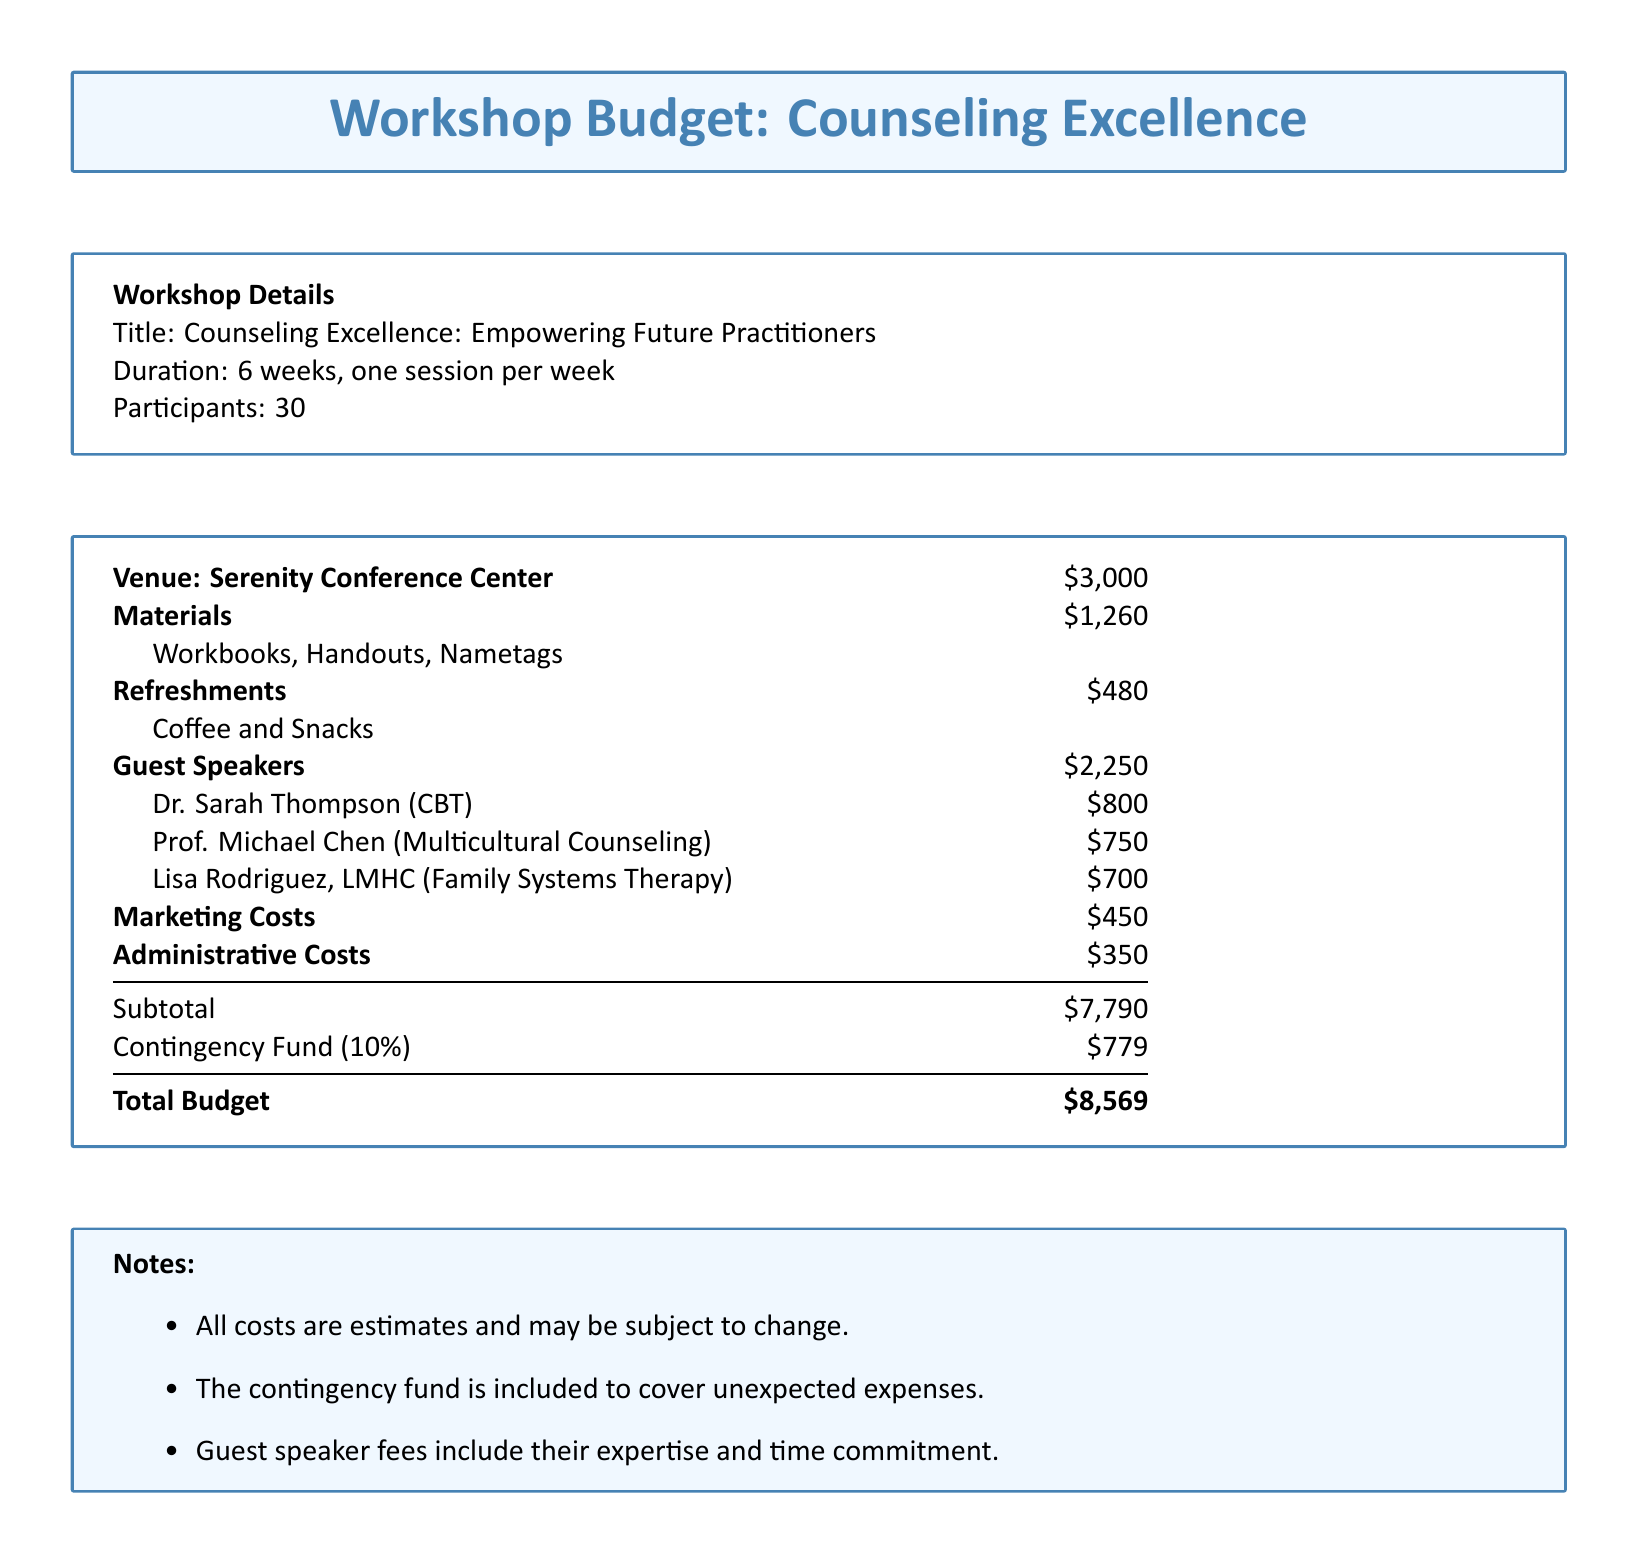What is the venue for the workshop? The venue is specifically mentioned as "Serenity Conference Center" in the document.
Answer: Serenity Conference Center What is the total budget for the workshop? The total budget is clearly stated at the end of the budget details.
Answer: $8,569 How many guest speakers are listed in the document? The document lists the names and fees of three guest speakers, indicating the total number.
Answer: 3 What is the cost for materials? The document specifies the cost of materials separately, showing the total amount allocated.
Answer: $1,260 What percentage is allocated for the contingency fund? The budget includes a note indicating the contingency fund as 10% of the subtotal.
Answer: 10% What is included in the refreshments cost? Referring to the details, it states that the refreshments include "Coffee and Snacks."
Answer: Coffee and Snacks What is the subtotal before including the contingency fund? The subtotal is explicitly mentioned in the document, which is before adding the contingency.
Answer: $7,790 What is the fee for Dr. Sarah Thompson? The document specifically lists her fee under guest speaker fees.
Answer: $800 